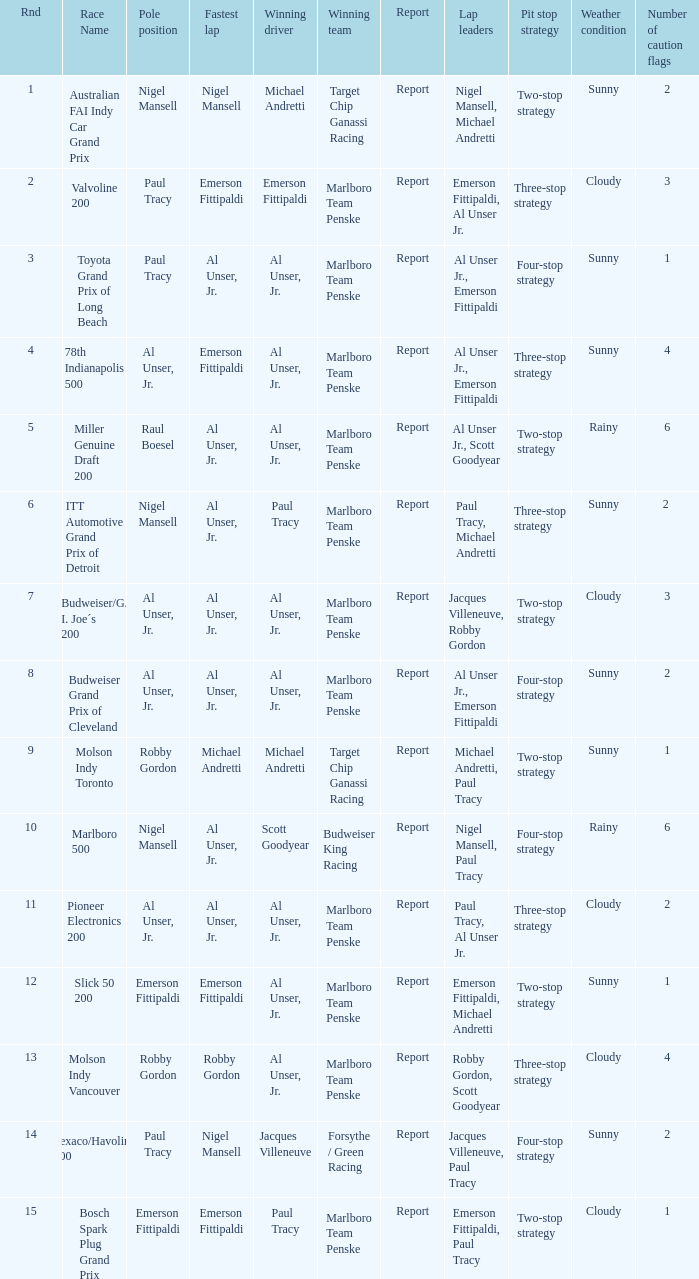Who was at the pole position in the ITT Automotive Grand Prix of Detroit, won by Paul Tracy? Nigel Mansell. 